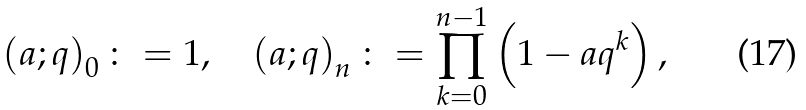Convert formula to latex. <formula><loc_0><loc_0><loc_500><loc_500>\left ( a ; q \right ) _ { 0 } \colon = 1 , \quad \left ( a ; q \right ) _ { n } \colon = \prod _ { k = 0 } ^ { n - 1 } \left ( 1 - a q ^ { k } \right ) ,</formula> 